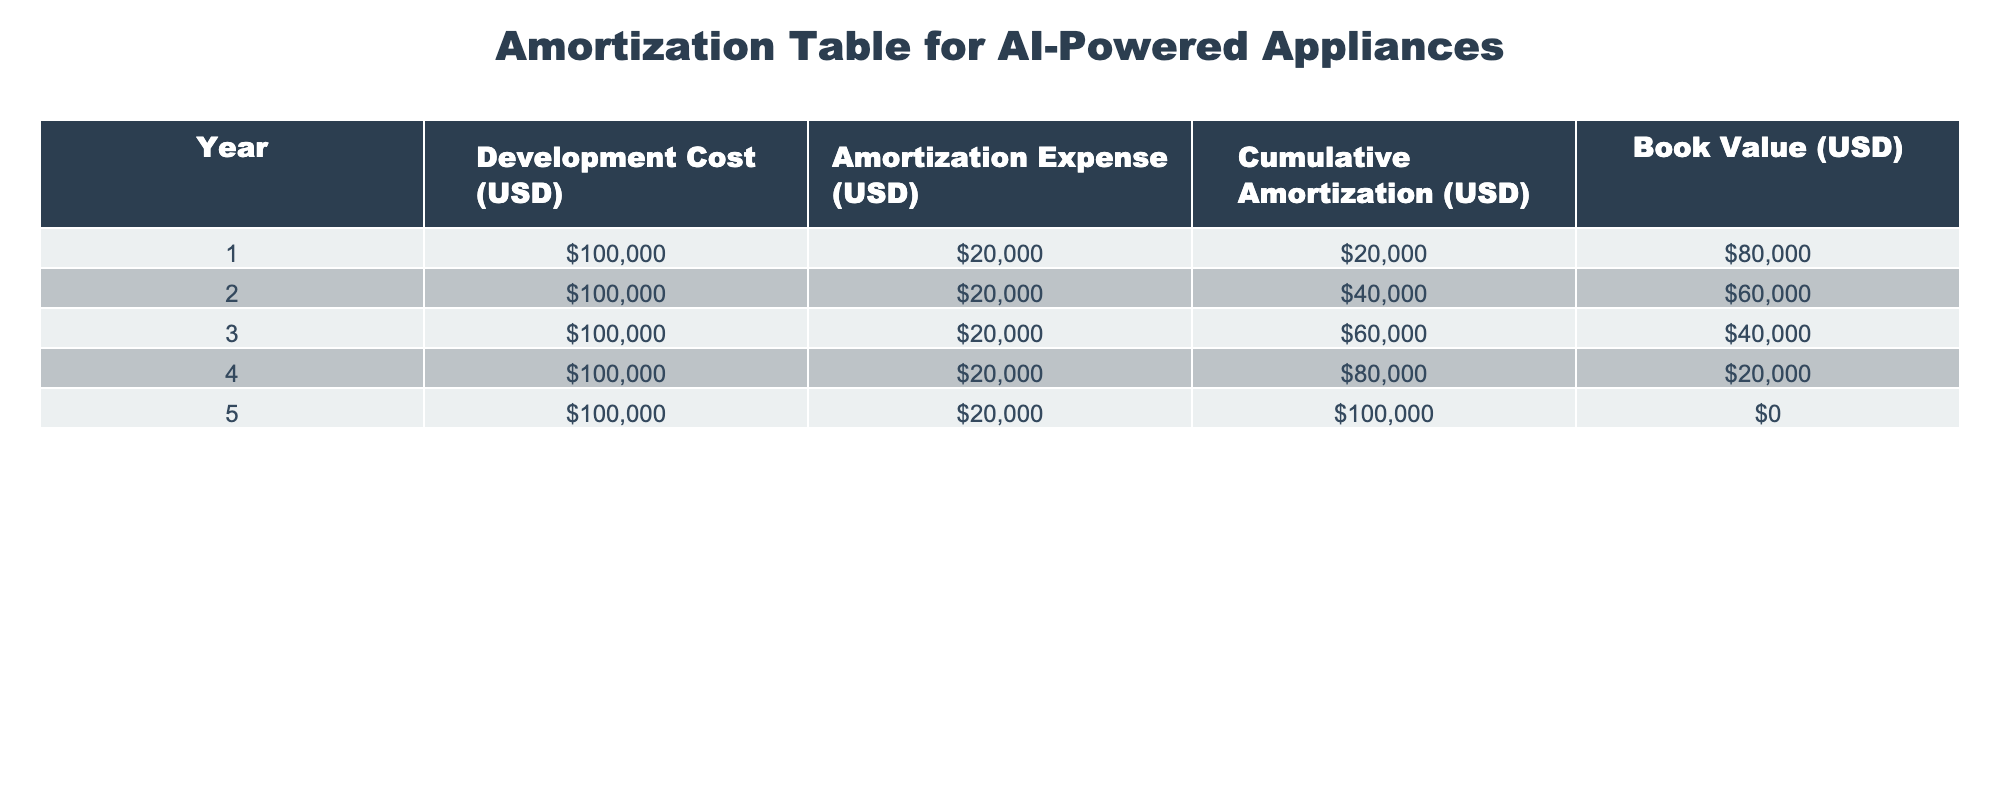What is the development cost for year 3? According to the table, the development cost listed for year 3 is 100,000 USD.
Answer: 100000 What is the amortization expense for year 5? The table shows that the amortization expense for year 5 is 20,000 USD.
Answer: 20000 What is the cumulative amortization at the end of year 2? From the table, the cumulative amortization at the end of year 2 is 40,000 USD, as stated in the corresponding row for year 2.
Answer: 40000 Is the book value at the end of year 4 greater than 30,000 USD? Referring to the table, the book value at the end of year 4 is 20,000 USD, which is less than 30,000 USD. Therefore, the statement is false.
Answer: No What is the total amortization expense over the 5 years? The amortization expense for each of the 5 years is 20,000 USD. Summing these amounts yields 20,000 + 20,000 + 20,000 + 20,000 + 20,000 = 100,000 USD as the total amortization over the period.
Answer: 100000 How much did the book value decrease from year 1 to year 3? The book value at the end of year 1 is 80,000 USD and at the end of year 3 it is 40,000 USD. The difference is 80,000 - 40,000 = 40,000 USD, indicating the book value decreased by this amount over those years.
Answer: 40000 Was the cumulative amortization at the end of year 4 the same as at the end of year 3? Looking at the table, the cumulative amortization at the end of year 4 is 80,000 USD, while at the end of year 3 it is 60,000 USD. Since these values are different, the answer is no.
Answer: No What is the average annual amortization expense over the 5-year period? Each year's amortization expense is 20,000 USD. To find the average, sum the expenses: 20,000 + 20,000 + 20,000 + 20,000 + 20,000 = 100,000 USD. Dividing by 5 (the number of years), the average is 100,000 / 5 = 20,000 USD.
Answer: 20000 What is the book value at the beginning of year 4? The book value at the end of year 3 is 40,000 USD, which is also the book value at the beginning of year 4 since it has not changed yet.
Answer: 40000 